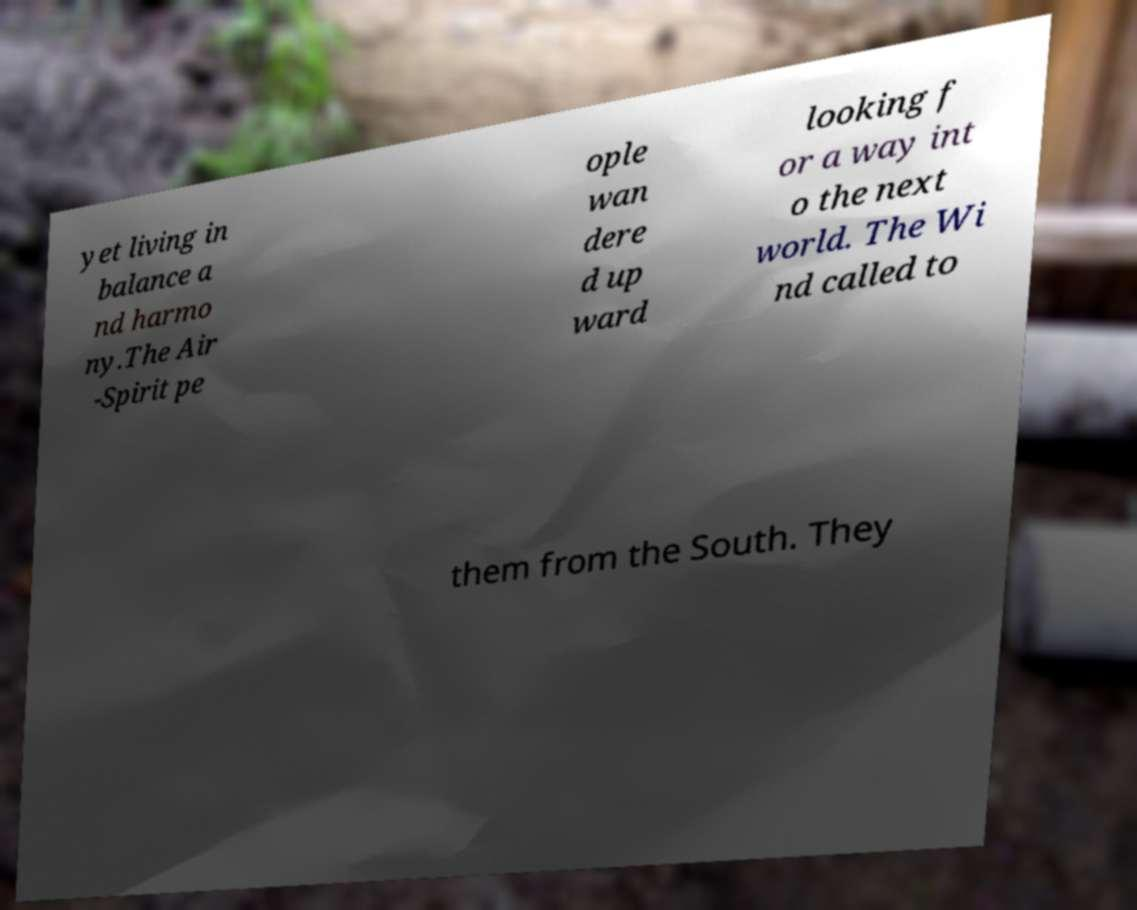There's text embedded in this image that I need extracted. Can you transcribe it verbatim? yet living in balance a nd harmo ny.The Air -Spirit pe ople wan dere d up ward looking f or a way int o the next world. The Wi nd called to them from the South. They 